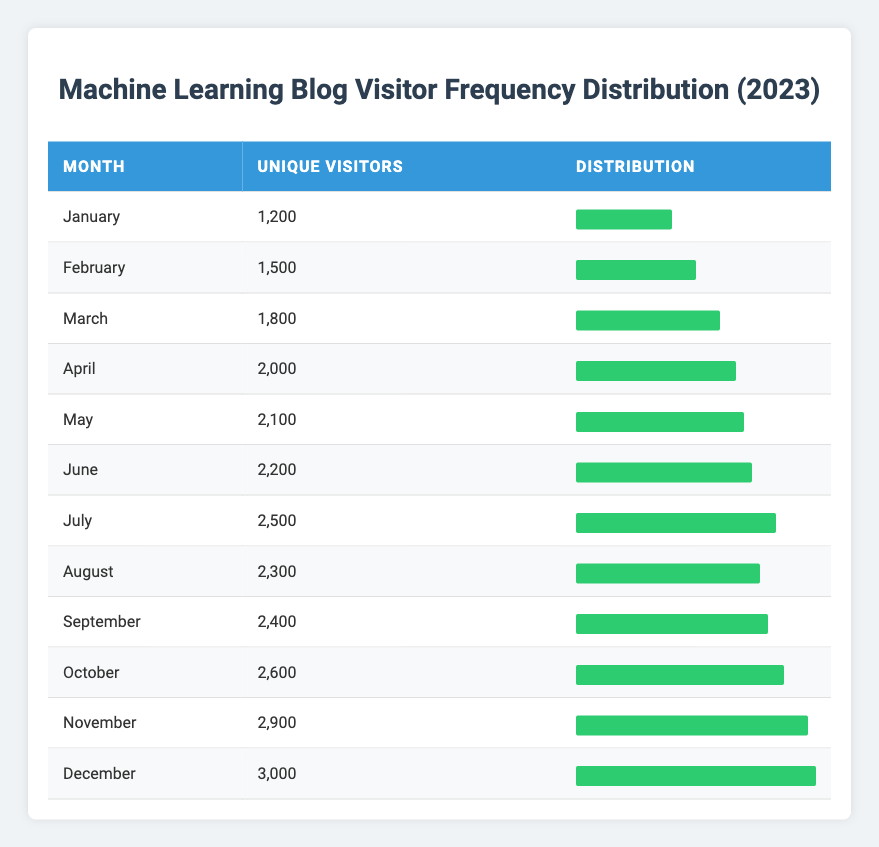What month had the highest unique visitor count? By looking at the table, December has the count of 3,000, which is the highest among all the months listed.
Answer: December How many unique visitors were there in July? The table shows that July had 2,500 unique visitors.
Answer: 2,500 What is the total number of unique visitors from January to June? First, sum the unique visitors for each month from January to June: 1,200 (January) + 1,500 (February) + 1,800 (March) + 2,000 (April) + 2,100 (May) + 2,200 (June) = 10,800.
Answer: 10,800 Was there an increase in unique visitors from February to March? The count increased from February (1,500) to March (1,800), which confirms there was an increase.
Answer: Yes What is the average number of unique visitors per month in 2023? To find the average, sum all the unique visitors from January to December (1,200 + 1,500 + 1,800 + 2,000 + 2,100 + 2,200 + 2,500 + 2,300 + 2,400 + 2,600 + 2,900 + 3,000 = 28,600) and then divide by 12 months, yielding: 28,600 / 12 = 2,383.33.
Answer: 2,383.33 Which month had the lowest unique visitor count? The table indicates that January had the lowest count of 1,200 unique visitors compared to the other months.
Answer: January Is the number of unique visitors in April greater than the average for the entire year? April has 2,000 unique visitors, and the average is 2,383.33, so 2,000 is less than the average.
Answer: No How many more unique visitors were there in December compared to January? December had 3,000 unique visitors and January had 1,200 unique visitors. The difference is 3,000 - 1,200 = 1,800.
Answer: 1,800 What percentage of the total unique visitors in 2023 came in November? To find the percentage of unique visitors in November, first calculate the total (28,600), then divide November’s count (2,900) by the total and multiply by 100: (2,900 / 28,600) * 100 = 10.14%.
Answer: 10.14% 